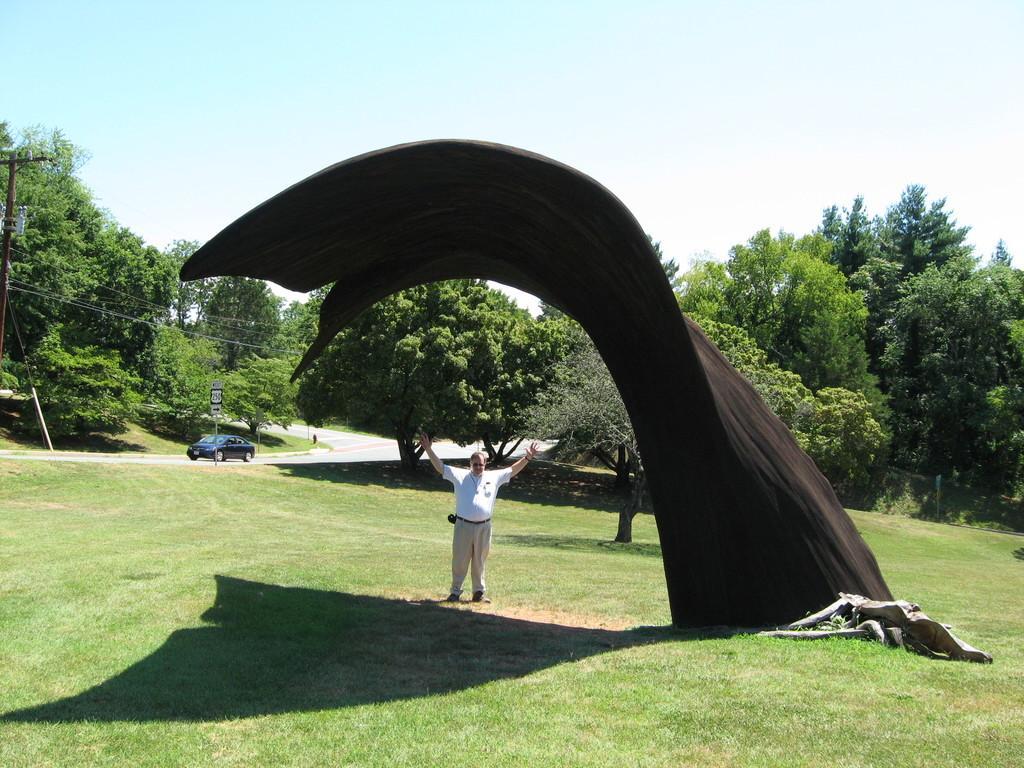In one or two sentences, can you explain what this image depicts? As we can see in the image there is grass, a man standing, black color cloth, trees, blue color car, sign pole and at the top there is sky. 